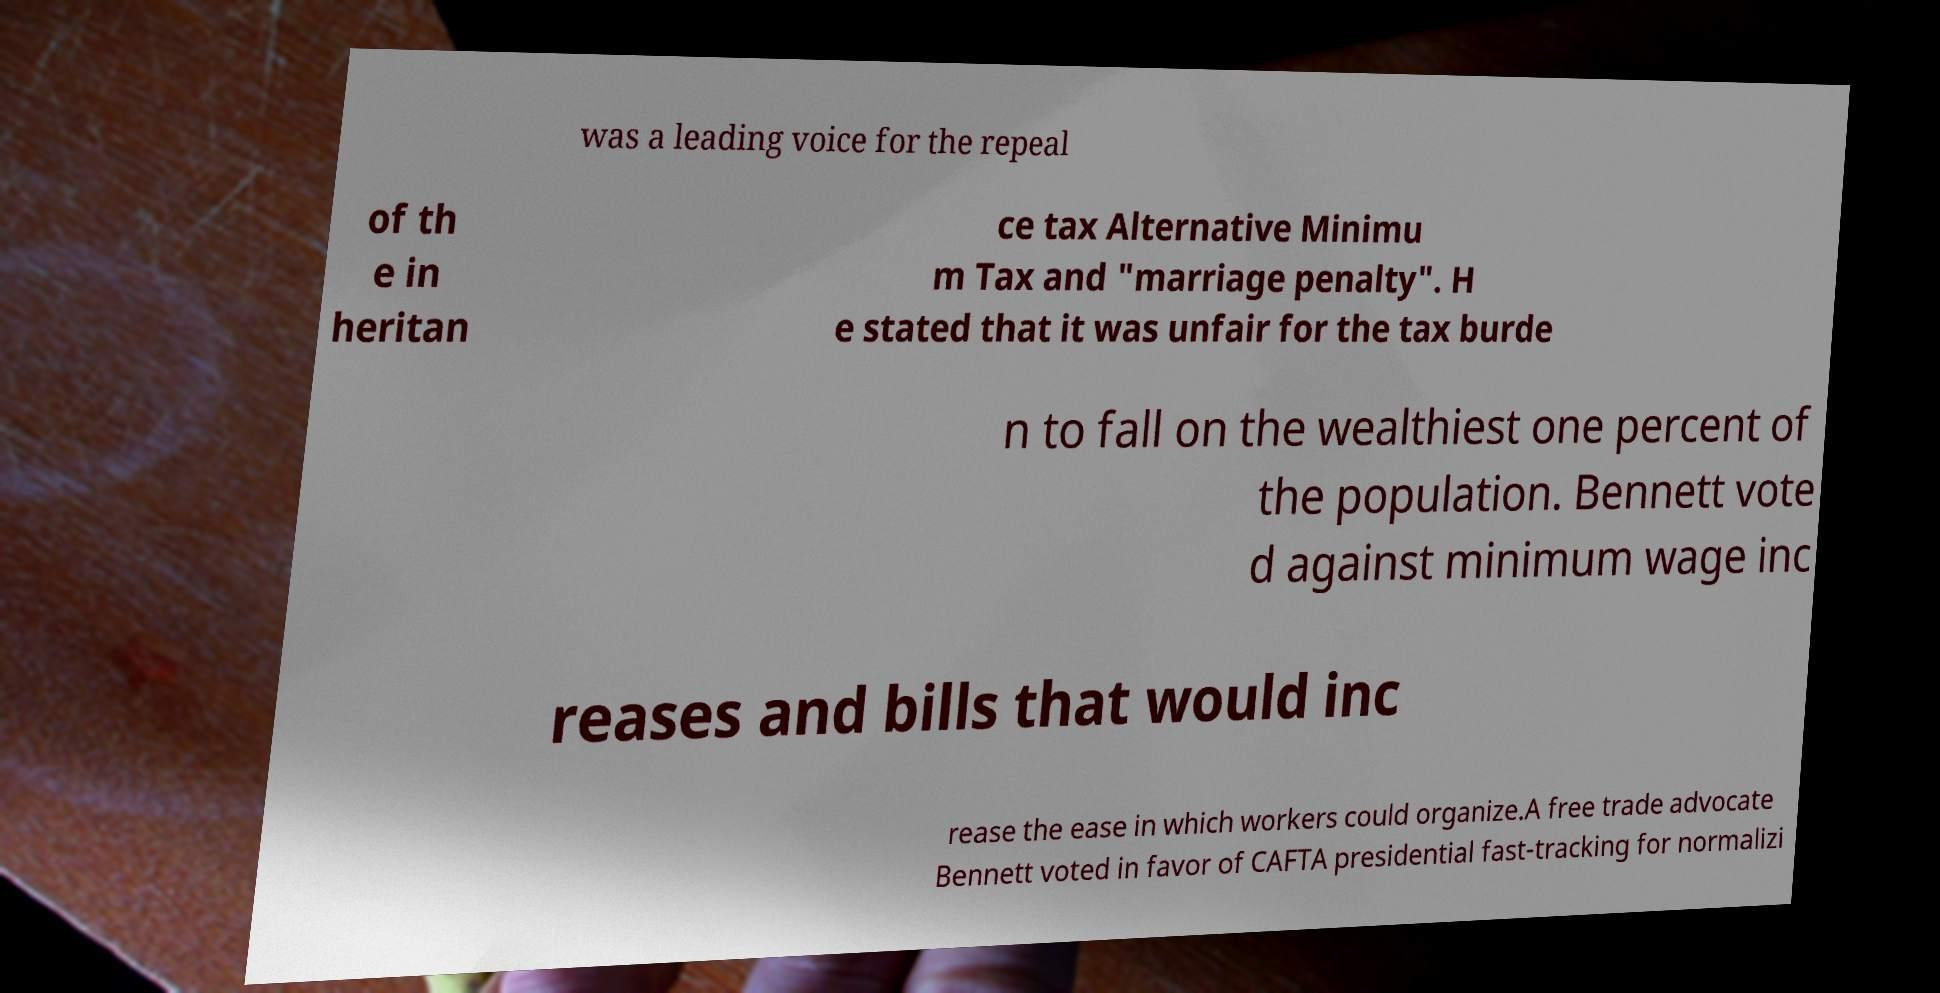Please read and relay the text visible in this image. What does it say? was a leading voice for the repeal of th e in heritan ce tax Alternative Minimu m Tax and "marriage penalty". H e stated that it was unfair for the tax burde n to fall on the wealthiest one percent of the population. Bennett vote d against minimum wage inc reases and bills that would inc rease the ease in which workers could organize.A free trade advocate Bennett voted in favor of CAFTA presidential fast-tracking for normalizi 